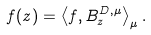<formula> <loc_0><loc_0><loc_500><loc_500>f ( z ) = \left \langle f , B _ { z } ^ { D , \mu } \right \rangle _ { \mu } .</formula> 